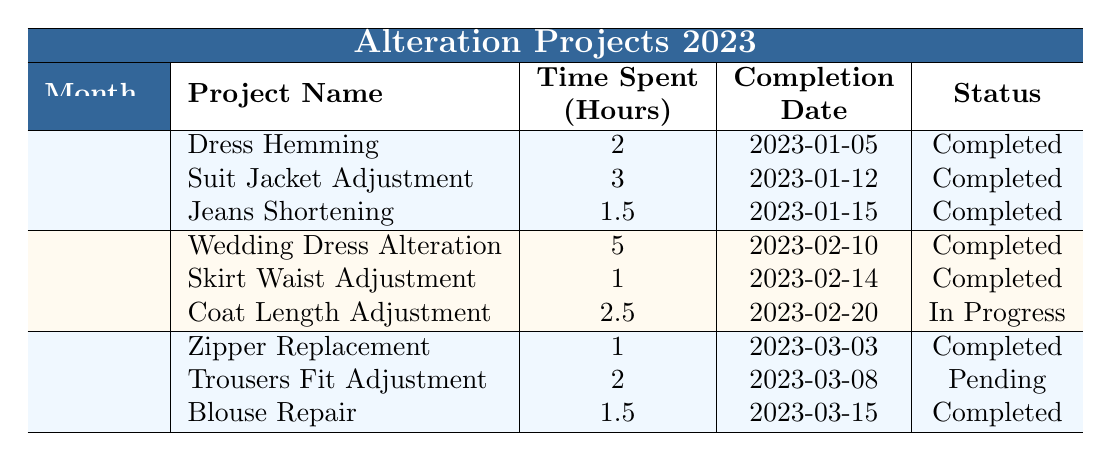What are the total hours spent on alteration projects in January? The hours spent in January are: 2 for Dress Hemming, 3 for Suit Jacket Adjustment, and 1.5 for Jeans Shortening. Adding these together: 2 + 3 + 1.5 = 6.5 hours.
Answer: 6.5 hours Which project had the longest time spent in February? In February, projects and their hours spent are: Wedding Dress Alteration (5 hours), Skirt Waist Adjustment (1 hour), and Coat Length Adjustment (2.5 hours). The longest is the Wedding Dress Alteration at 5 hours.
Answer: Wedding Dress Alteration Did any project in March have a status of "In Progress"? In March, the statuses are: Zipper Replacement (Completed), Trousers Fit Adjustment (Pending), and Blouse Repair (Completed). None of them are "In Progress".
Answer: No How many projects were completed across the three months? In January, there are 3 completed projects; in February, 2 completed projects; and in March, there are 3 completed projects. Adding these: 3 + 2 + 3 = 8 completed projects.
Answer: 8 projects What is the average time spent on completed projects in January? The completed projects in January are: Dress Hemming (2 hours), Suit Jacket Adjustment (3 hours), and Jeans Shortening (1.5 hours). The total time spent is 2 + 3 + 1.5 = 6.5 hours, and there are 3 completed projects. The average is 6.5 / 3 = 2.17 hours.
Answer: 2.17 hours Which month had the highest number of completed projects? The completed projects by month are January (3), February (2), and March (3). Both January and March have the highest number with 3 projects each.
Answer: January and March Is there any project listed in January that was not completed? Reviewing January's projects: Dress Hemming (Completed), Suit Jacket Adjustment (Completed), and Jeans Shortening (Completed). All were completed, so there are no incomplete projects.
Answer: No What proportion of the projects in February are currently "In Progress"? In February, there are 3 projects: Wedding Dress Alteration (Completed), Skirt Waist Adjustment (Completed), and Coat Length Adjustment (In Progress). Out of 3 projects, only 1 is "In Progress". Thus, the proportion is 1 out of 3 or 1/3.
Answer: 1/3 